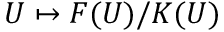Convert formula to latex. <formula><loc_0><loc_0><loc_500><loc_500>U \mapsto F ( U ) / K ( U )</formula> 